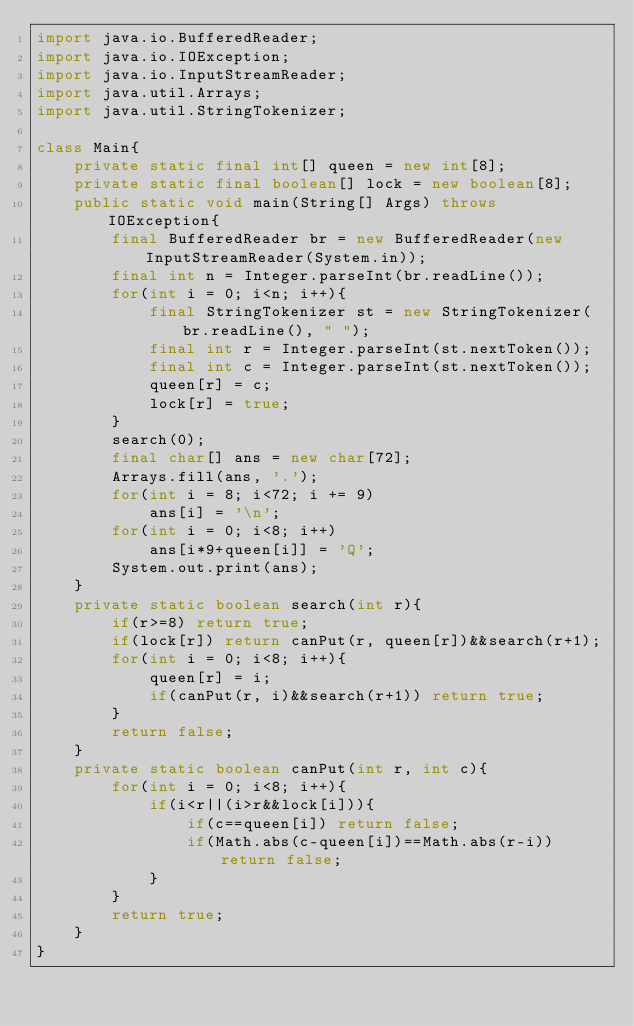<code> <loc_0><loc_0><loc_500><loc_500><_Java_>import java.io.BufferedReader;
import java.io.IOException;
import java.io.InputStreamReader;
import java.util.Arrays;
import java.util.StringTokenizer;

class Main{
    private static final int[] queen = new int[8];
    private static final boolean[] lock = new boolean[8];
    public static void main(String[] Args) throws IOException{
        final BufferedReader br = new BufferedReader(new InputStreamReader(System.in));
        final int n = Integer.parseInt(br.readLine());
        for(int i = 0; i<n; i++){
            final StringTokenizer st = new StringTokenizer(br.readLine(), " ");
            final int r = Integer.parseInt(st.nextToken());
            final int c = Integer.parseInt(st.nextToken());
            queen[r] = c;
            lock[r] = true;
        }
        search(0);
        final char[] ans = new char[72];
        Arrays.fill(ans, '.');
        for(int i = 8; i<72; i += 9)
            ans[i] = '\n';
        for(int i = 0; i<8; i++)
            ans[i*9+queen[i]] = 'Q';
        System.out.print(ans);
    }
    private static boolean search(int r){
        if(r>=8) return true;
        if(lock[r]) return canPut(r, queen[r])&&search(r+1);
        for(int i = 0; i<8; i++){
            queen[r] = i;
            if(canPut(r, i)&&search(r+1)) return true;
        }
        return false;
    }
    private static boolean canPut(int r, int c){
        for(int i = 0; i<8; i++){
            if(i<r||(i>r&&lock[i])){
                if(c==queen[i]) return false;
                if(Math.abs(c-queen[i])==Math.abs(r-i)) return false;
            }
        }
        return true;
    }
}</code> 